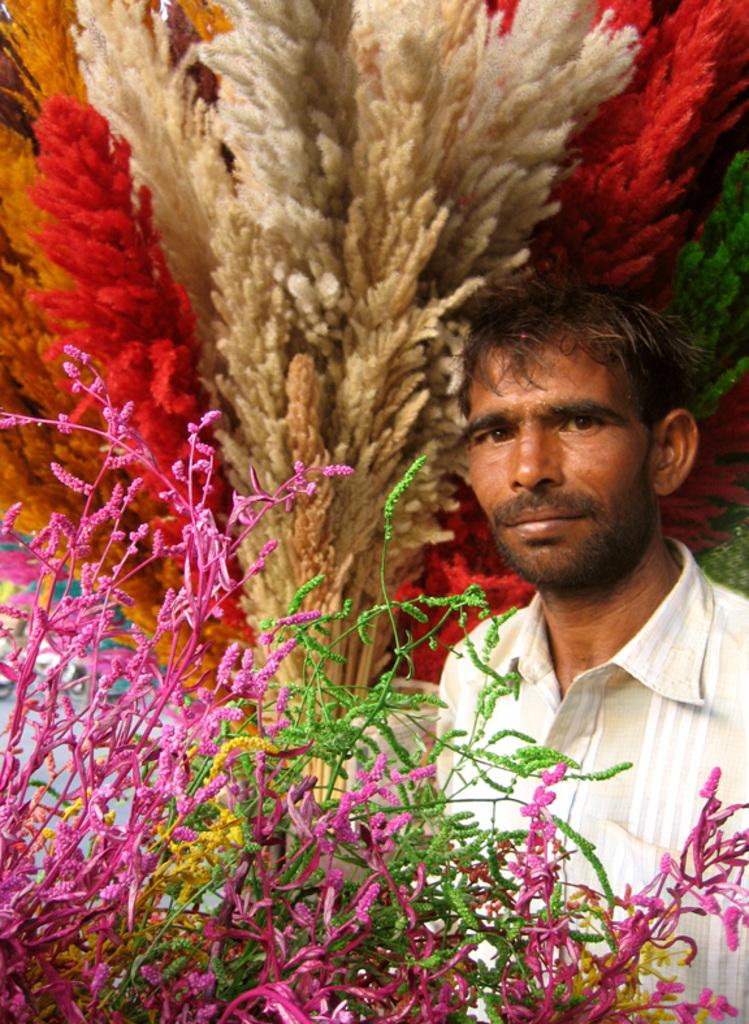What is the position of the man in the image? The man is standing on the right side of the image. What is the man wearing in the image? The man is wearing a shirt in the image. Can you describe the background of the image? There is decor visible in the background of the image. What type of drink is the man holding in the image? There is no drink visible in the image; the man is not holding anything. 